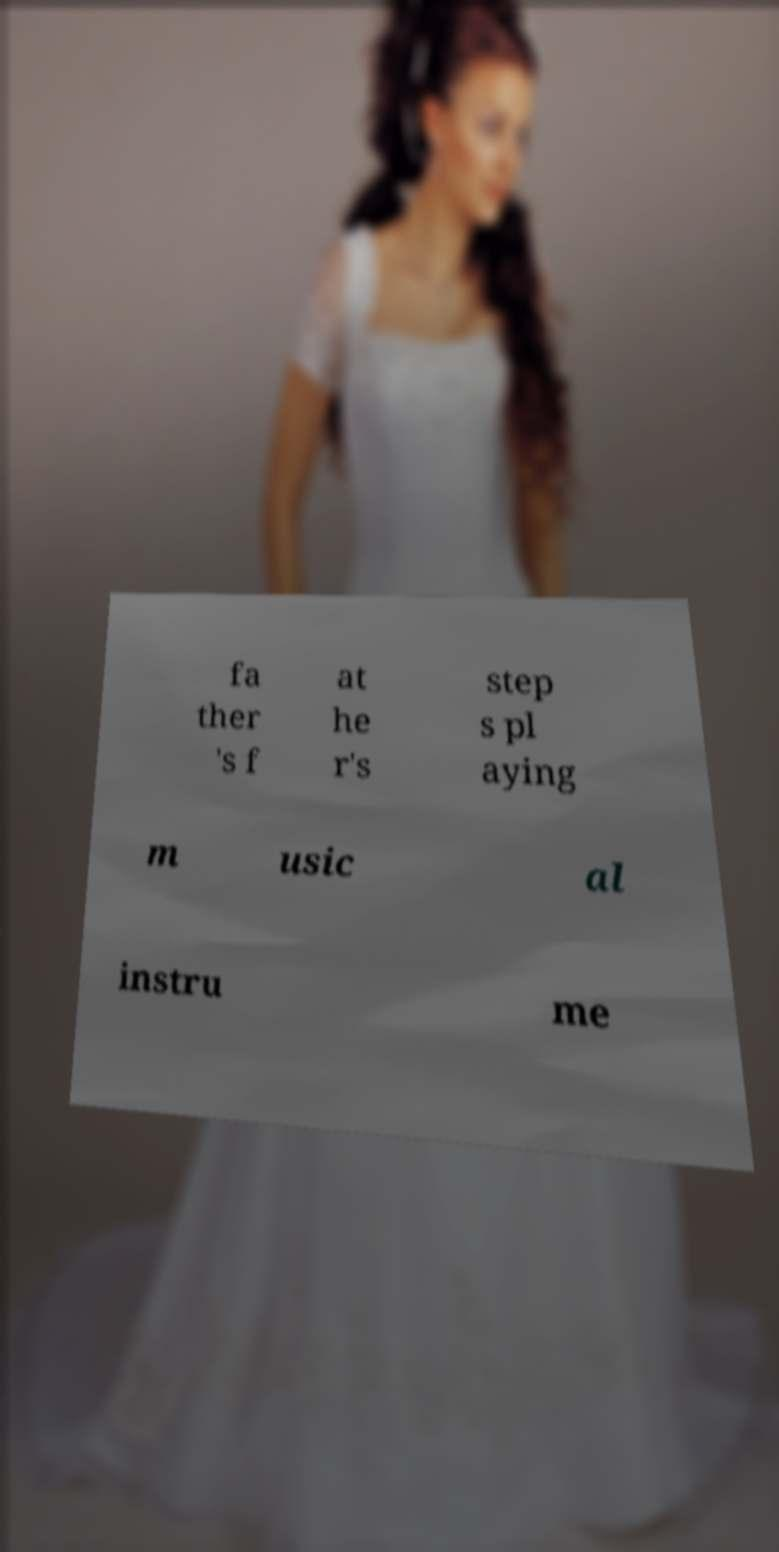Please read and relay the text visible in this image. What does it say? fa ther 's f at he r's step s pl aying m usic al instru me 